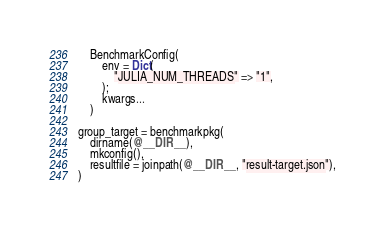<code> <loc_0><loc_0><loc_500><loc_500><_Julia_>    BenchmarkConfig(
        env = Dict(
            "JULIA_NUM_THREADS" => "1",
        );
        kwargs...
    )

group_target = benchmarkpkg(
    dirname(@__DIR__),
    mkconfig(),
    resultfile = joinpath(@__DIR__, "result-target.json"),
)
</code> 